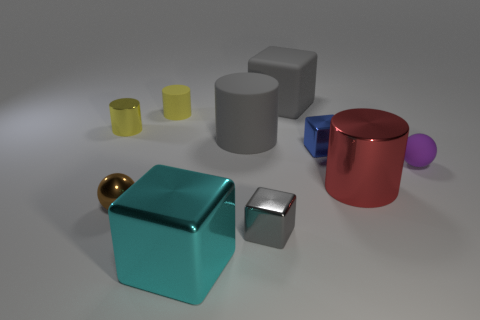There is a tiny rubber thing left of the purple rubber thing; what is its shape?
Keep it short and to the point. Cylinder. There is a tiny thing that is the same color as the small rubber cylinder; what shape is it?
Provide a succinct answer. Cylinder. What number of blue things are the same size as the purple object?
Give a very brief answer. 1. The small metallic cylinder has what color?
Make the answer very short. Yellow. There is a big metal cylinder; does it have the same color as the large block that is behind the yellow matte object?
Ensure brevity in your answer.  No. There is a yellow cylinder that is made of the same material as the brown thing; what is its size?
Keep it short and to the point. Small. Are there any tiny shiny cylinders that have the same color as the small metallic sphere?
Give a very brief answer. No. What number of things are either yellow cylinders to the right of the tiny brown object or small metal balls?
Provide a succinct answer. 2. Is the brown ball made of the same material as the large gray thing that is in front of the small yellow rubber thing?
Provide a succinct answer. No. There is a rubber thing that is the same color as the big matte cylinder; what is its size?
Your response must be concise. Large. 